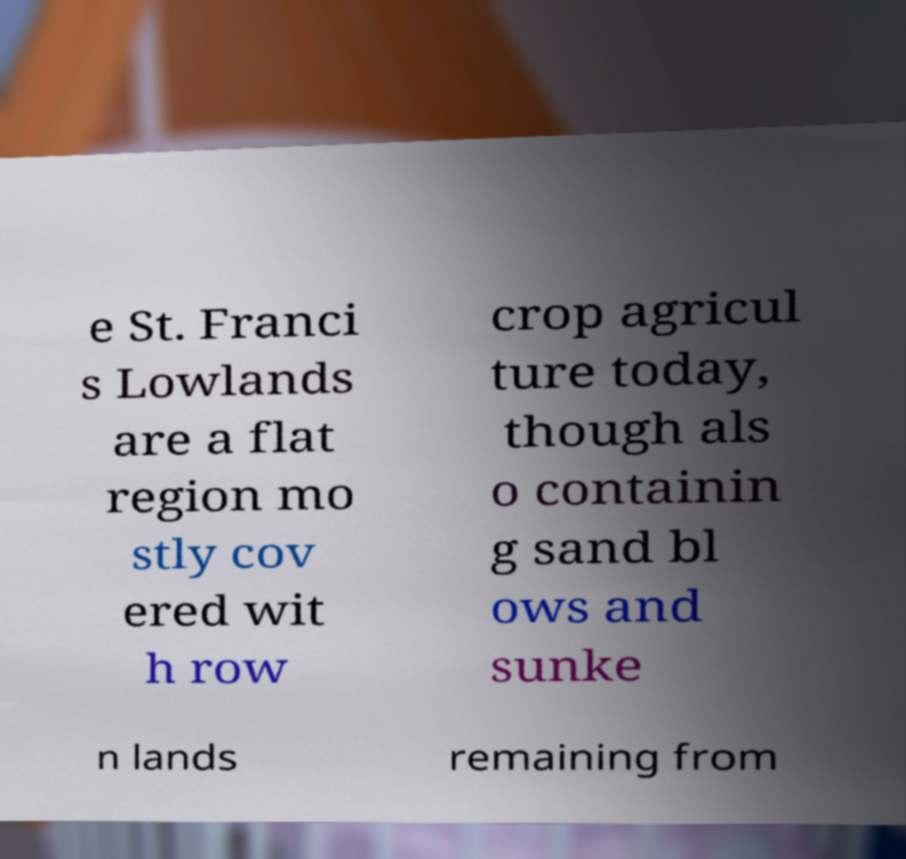Can you read and provide the text displayed in the image?This photo seems to have some interesting text. Can you extract and type it out for me? e St. Franci s Lowlands are a flat region mo stly cov ered wit h row crop agricul ture today, though als o containin g sand bl ows and sunke n lands remaining from 